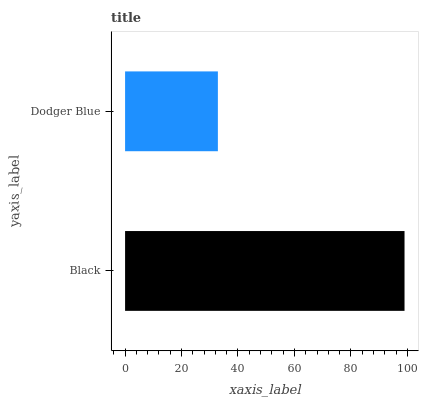Is Dodger Blue the minimum?
Answer yes or no. Yes. Is Black the maximum?
Answer yes or no. Yes. Is Dodger Blue the maximum?
Answer yes or no. No. Is Black greater than Dodger Blue?
Answer yes or no. Yes. Is Dodger Blue less than Black?
Answer yes or no. Yes. Is Dodger Blue greater than Black?
Answer yes or no. No. Is Black less than Dodger Blue?
Answer yes or no. No. Is Black the high median?
Answer yes or no. Yes. Is Dodger Blue the low median?
Answer yes or no. Yes. Is Dodger Blue the high median?
Answer yes or no. No. Is Black the low median?
Answer yes or no. No. 